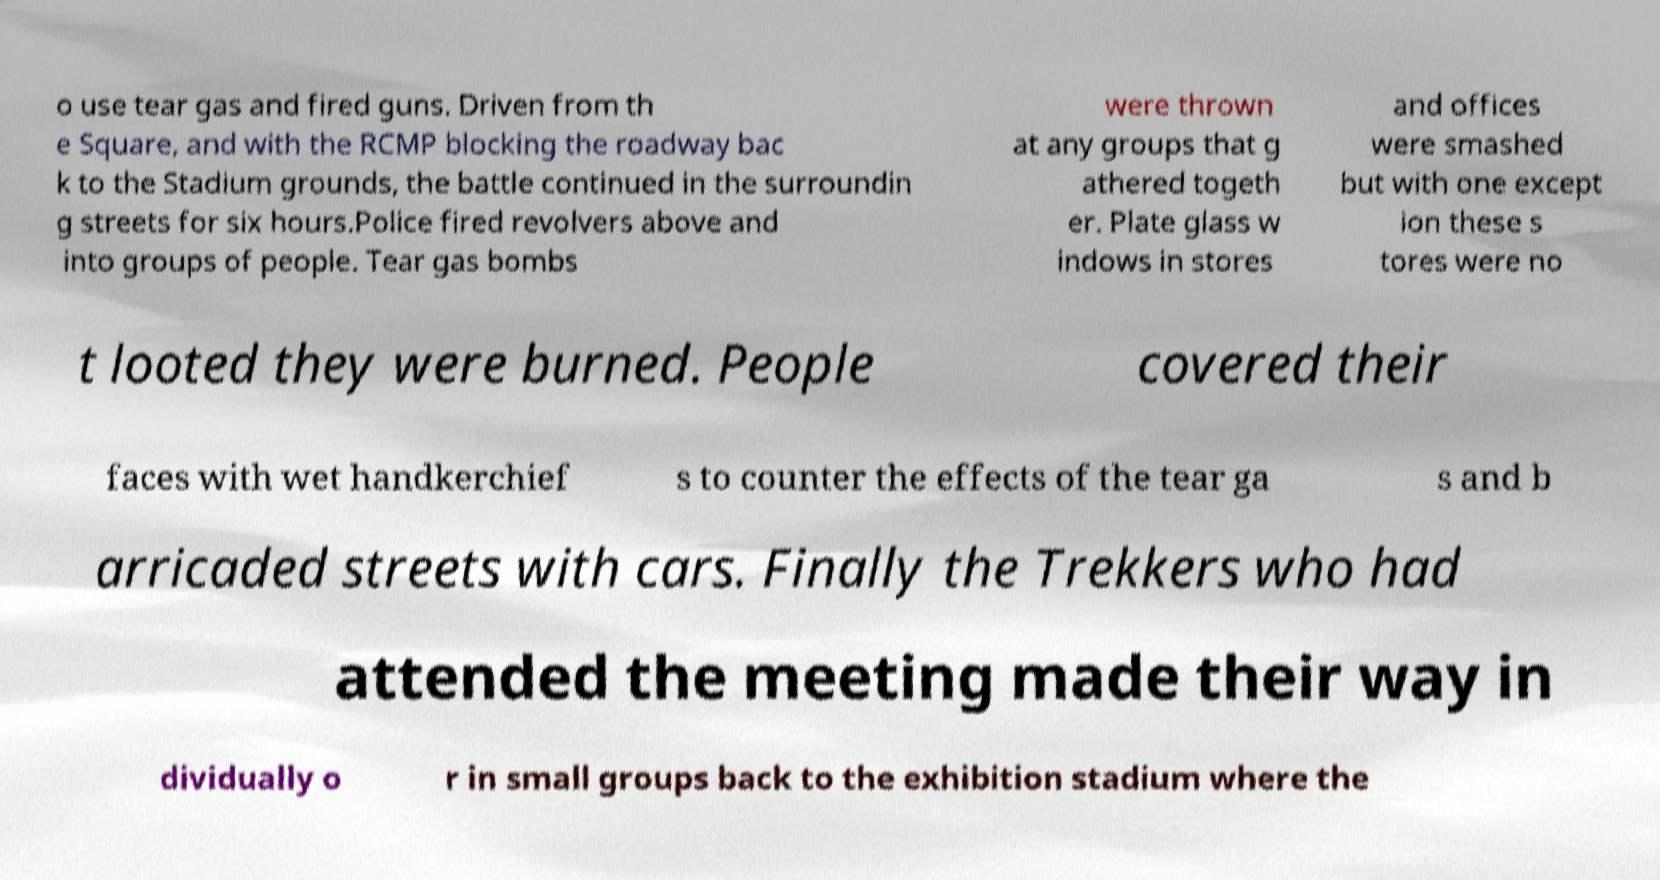Can you accurately transcribe the text from the provided image for me? o use tear gas and fired guns. Driven from th e Square, and with the RCMP blocking the roadway bac k to the Stadium grounds, the battle continued in the surroundin g streets for six hours.Police fired revolvers above and into groups of people. Tear gas bombs were thrown at any groups that g athered togeth er. Plate glass w indows in stores and offices were smashed but with one except ion these s tores were no t looted they were burned. People covered their faces with wet handkerchief s to counter the effects of the tear ga s and b arricaded streets with cars. Finally the Trekkers who had attended the meeting made their way in dividually o r in small groups back to the exhibition stadium where the 